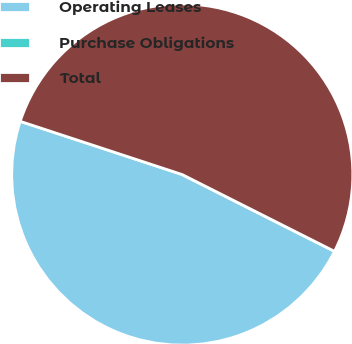<chart> <loc_0><loc_0><loc_500><loc_500><pie_chart><fcel>Operating Leases<fcel>Purchase Obligations<fcel>Total<nl><fcel>47.62%<fcel>0.0%<fcel>52.38%<nl></chart> 